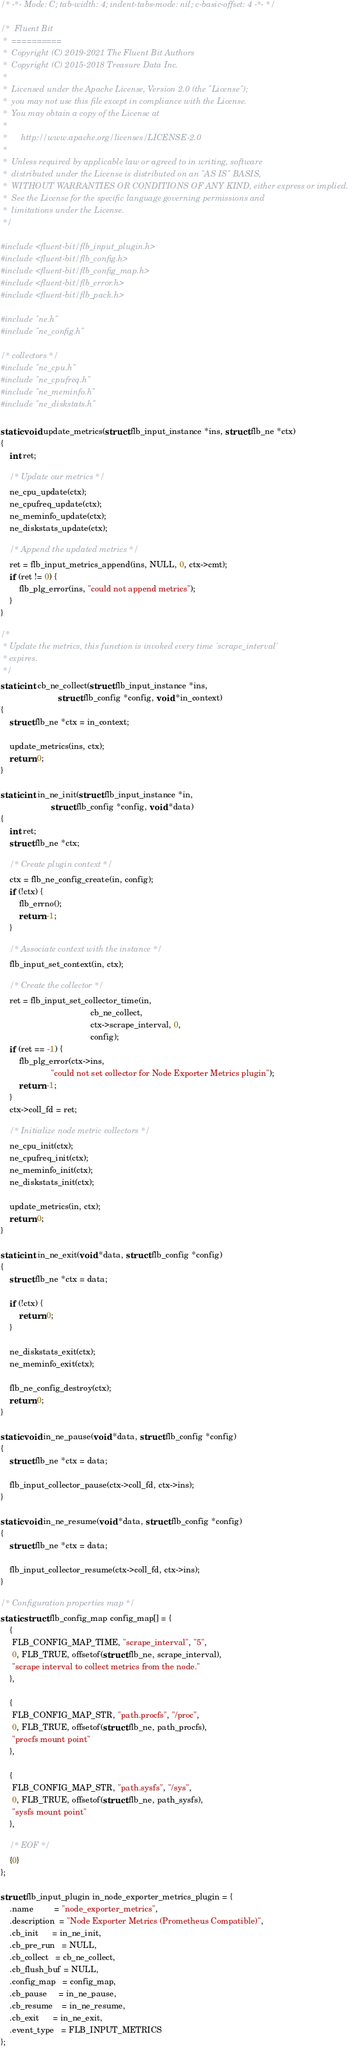<code> <loc_0><loc_0><loc_500><loc_500><_C_>/* -*- Mode: C; tab-width: 4; indent-tabs-mode: nil; c-basic-offset: 4 -*- */

/*  Fluent Bit
 *  ==========
 *  Copyright (C) 2019-2021 The Fluent Bit Authors
 *  Copyright (C) 2015-2018 Treasure Data Inc.
 *
 *  Licensed under the Apache License, Version 2.0 (the "License");
 *  you may not use this file except in compliance with the License.
 *  You may obtain a copy of the License at
 *
 *      http://www.apache.org/licenses/LICENSE-2.0
 *
 *  Unless required by applicable law or agreed to in writing, software
 *  distributed under the License is distributed on an "AS IS" BASIS,
 *  WITHOUT WARRANTIES OR CONDITIONS OF ANY KIND, either express or implied.
 *  See the License for the specific language governing permissions and
 *  limitations under the License.
 */

#include <fluent-bit/flb_input_plugin.h>
#include <fluent-bit/flb_config.h>
#include <fluent-bit/flb_config_map.h>
#include <fluent-bit/flb_error.h>
#include <fluent-bit/flb_pack.h>

#include "ne.h"
#include "ne_config.h"

/* collectors */
#include "ne_cpu.h"
#include "ne_cpufreq.h"
#include "ne_meminfo.h"
#include "ne_diskstats.h"

static void update_metrics(struct flb_input_instance *ins, struct flb_ne *ctx)
{
    int ret;

    /* Update our metrics */
    ne_cpu_update(ctx);
    ne_cpufreq_update(ctx);
    ne_meminfo_update(ctx);
    ne_diskstats_update(ctx);

    /* Append the updated metrics */
    ret = flb_input_metrics_append(ins, NULL, 0, ctx->cmt);
    if (ret != 0) {
        flb_plg_error(ins, "could not append metrics");
    }
}

/*
 * Update the metrics, this function is invoked every time 'scrape_interval'
 * expires.
 */
static int cb_ne_collect(struct flb_input_instance *ins,
                         struct flb_config *config, void *in_context)
{
    struct flb_ne *ctx = in_context;

    update_metrics(ins, ctx);
    return 0;
}

static int in_ne_init(struct flb_input_instance *in,
                      struct flb_config *config, void *data)
{
    int ret;
    struct flb_ne *ctx;

    /* Create plugin context */
    ctx = flb_ne_config_create(in, config);
    if (!ctx) {
        flb_errno();
        return -1;
    }

    /* Associate context with the instance */
    flb_input_set_context(in, ctx);

    /* Create the collector */
    ret = flb_input_set_collector_time(in,
                                       cb_ne_collect,
                                       ctx->scrape_interval, 0,
                                       config);
    if (ret == -1) {
        flb_plg_error(ctx->ins,
                      "could not set collector for Node Exporter Metrics plugin");
        return -1;
    }
    ctx->coll_fd = ret;

    /* Initialize node metric collectors */
    ne_cpu_init(ctx);
    ne_cpufreq_init(ctx);
    ne_meminfo_init(ctx);
    ne_diskstats_init(ctx);

    update_metrics(in, ctx);
    return 0;
}

static int in_ne_exit(void *data, struct flb_config *config)
{
    struct flb_ne *ctx = data;

    if (!ctx) {
        return 0;
    }

    ne_diskstats_exit(ctx);
    ne_meminfo_exit(ctx);

    flb_ne_config_destroy(ctx);
    return 0;
}

static void in_ne_pause(void *data, struct flb_config *config)
{
    struct flb_ne *ctx = data;

    flb_input_collector_pause(ctx->coll_fd, ctx->ins);
}

static void in_ne_resume(void *data, struct flb_config *config)
{
    struct flb_ne *ctx = data;

    flb_input_collector_resume(ctx->coll_fd, ctx->ins);
}

/* Configuration properties map */
static struct flb_config_map config_map[] = {
    {
     FLB_CONFIG_MAP_TIME, "scrape_interval", "5",
     0, FLB_TRUE, offsetof(struct flb_ne, scrape_interval),
     "scrape interval to collect metrics from the node."
    },

    {
     FLB_CONFIG_MAP_STR, "path.procfs", "/proc",
     0, FLB_TRUE, offsetof(struct flb_ne, path_procfs),
     "procfs mount point"
    },

    {
     FLB_CONFIG_MAP_STR, "path.sysfs", "/sys",
     0, FLB_TRUE, offsetof(struct flb_ne, path_sysfs),
     "sysfs mount point"
    },

    /* EOF */
    {0}
};

struct flb_input_plugin in_node_exporter_metrics_plugin = {
    .name         = "node_exporter_metrics",
    .description  = "Node Exporter Metrics (Prometheus Compatible)",
    .cb_init      = in_ne_init,
    .cb_pre_run   = NULL,
    .cb_collect   = cb_ne_collect,
    .cb_flush_buf = NULL,
    .config_map   = config_map,
    .cb_pause     = in_ne_pause,
    .cb_resume    = in_ne_resume,
    .cb_exit      = in_ne_exit,
    .event_type   = FLB_INPUT_METRICS
};
</code> 